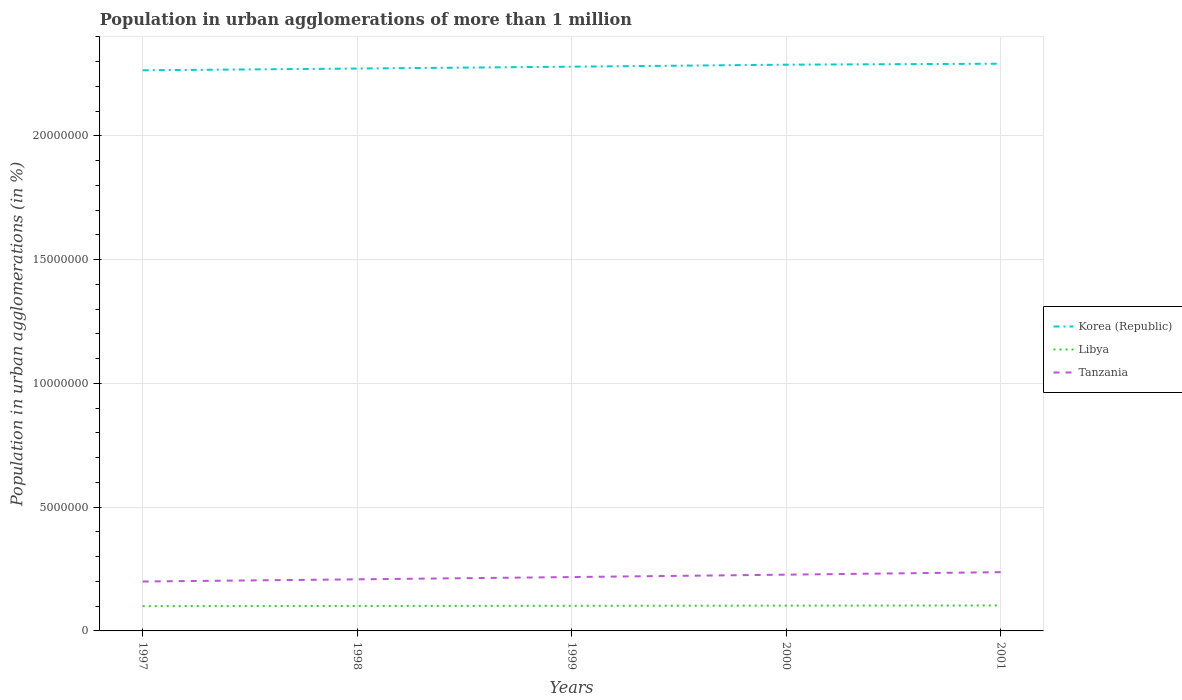How many different coloured lines are there?
Provide a succinct answer. 3. Is the number of lines equal to the number of legend labels?
Provide a succinct answer. Yes. Across all years, what is the maximum population in urban agglomerations in Korea (Republic)?
Ensure brevity in your answer.  2.26e+07. In which year was the population in urban agglomerations in Korea (Republic) maximum?
Your answer should be very brief. 1997. What is the total population in urban agglomerations in Korea (Republic) in the graph?
Your answer should be compact. -2.26e+05. What is the difference between the highest and the second highest population in urban agglomerations in Libya?
Keep it short and to the point. 2.82e+04. Is the population in urban agglomerations in Libya strictly greater than the population in urban agglomerations in Korea (Republic) over the years?
Make the answer very short. Yes. How many lines are there?
Make the answer very short. 3. Does the graph contain any zero values?
Your response must be concise. No. What is the title of the graph?
Provide a succinct answer. Population in urban agglomerations of more than 1 million. What is the label or title of the Y-axis?
Give a very brief answer. Population in urban agglomerations (in %). What is the Population in urban agglomerations (in %) of Korea (Republic) in 1997?
Make the answer very short. 2.26e+07. What is the Population in urban agglomerations (in %) of Libya in 1997?
Offer a terse response. 1.00e+06. What is the Population in urban agglomerations (in %) of Tanzania in 1997?
Give a very brief answer. 2.00e+06. What is the Population in urban agglomerations (in %) in Korea (Republic) in 1998?
Provide a succinct answer. 2.27e+07. What is the Population in urban agglomerations (in %) in Libya in 1998?
Ensure brevity in your answer.  1.01e+06. What is the Population in urban agglomerations (in %) in Tanzania in 1998?
Keep it short and to the point. 2.08e+06. What is the Population in urban agglomerations (in %) of Korea (Republic) in 1999?
Offer a very short reply. 2.28e+07. What is the Population in urban agglomerations (in %) of Libya in 1999?
Ensure brevity in your answer.  1.01e+06. What is the Population in urban agglomerations (in %) of Tanzania in 1999?
Ensure brevity in your answer.  2.18e+06. What is the Population in urban agglomerations (in %) of Korea (Republic) in 2000?
Provide a short and direct response. 2.29e+07. What is the Population in urban agglomerations (in %) in Libya in 2000?
Your response must be concise. 1.02e+06. What is the Population in urban agglomerations (in %) in Tanzania in 2000?
Offer a terse response. 2.27e+06. What is the Population in urban agglomerations (in %) of Korea (Republic) in 2001?
Make the answer very short. 2.29e+07. What is the Population in urban agglomerations (in %) in Libya in 2001?
Provide a succinct answer. 1.03e+06. What is the Population in urban agglomerations (in %) of Tanzania in 2001?
Your answer should be compact. 2.37e+06. Across all years, what is the maximum Population in urban agglomerations (in %) in Korea (Republic)?
Give a very brief answer. 2.29e+07. Across all years, what is the maximum Population in urban agglomerations (in %) in Libya?
Your answer should be very brief. 1.03e+06. Across all years, what is the maximum Population in urban agglomerations (in %) of Tanzania?
Offer a very short reply. 2.37e+06. Across all years, what is the minimum Population in urban agglomerations (in %) of Korea (Republic)?
Keep it short and to the point. 2.26e+07. Across all years, what is the minimum Population in urban agglomerations (in %) of Libya?
Your answer should be compact. 1.00e+06. Across all years, what is the minimum Population in urban agglomerations (in %) in Tanzania?
Offer a terse response. 2.00e+06. What is the total Population in urban agglomerations (in %) in Korea (Republic) in the graph?
Give a very brief answer. 1.14e+08. What is the total Population in urban agglomerations (in %) in Libya in the graph?
Give a very brief answer. 5.07e+06. What is the total Population in urban agglomerations (in %) in Tanzania in the graph?
Provide a succinct answer. 1.09e+07. What is the difference between the Population in urban agglomerations (in %) of Korea (Republic) in 1997 and that in 1998?
Provide a succinct answer. -7.04e+04. What is the difference between the Population in urban agglomerations (in %) in Libya in 1997 and that in 1998?
Provide a short and direct response. -6976. What is the difference between the Population in urban agglomerations (in %) of Tanzania in 1997 and that in 1998?
Provide a succinct answer. -8.83e+04. What is the difference between the Population in urban agglomerations (in %) in Korea (Republic) in 1997 and that in 1999?
Your response must be concise. -1.46e+05. What is the difference between the Population in urban agglomerations (in %) in Libya in 1997 and that in 1999?
Your answer should be compact. -1.40e+04. What is the difference between the Population in urban agglomerations (in %) in Tanzania in 1997 and that in 1999?
Keep it short and to the point. -1.80e+05. What is the difference between the Population in urban agglomerations (in %) of Korea (Republic) in 1997 and that in 2000?
Offer a very short reply. -2.26e+05. What is the difference between the Population in urban agglomerations (in %) in Libya in 1997 and that in 2000?
Offer a very short reply. -2.11e+04. What is the difference between the Population in urban agglomerations (in %) in Tanzania in 1997 and that in 2000?
Offer a terse response. -2.77e+05. What is the difference between the Population in urban agglomerations (in %) of Korea (Republic) in 1997 and that in 2001?
Make the answer very short. -2.66e+05. What is the difference between the Population in urban agglomerations (in %) in Libya in 1997 and that in 2001?
Your answer should be very brief. -2.82e+04. What is the difference between the Population in urban agglomerations (in %) of Tanzania in 1997 and that in 2001?
Your answer should be compact. -3.77e+05. What is the difference between the Population in urban agglomerations (in %) in Korea (Republic) in 1998 and that in 1999?
Your answer should be very brief. -7.54e+04. What is the difference between the Population in urban agglomerations (in %) of Libya in 1998 and that in 1999?
Provide a succinct answer. -7025. What is the difference between the Population in urban agglomerations (in %) in Tanzania in 1998 and that in 1999?
Provide a succinct answer. -9.22e+04. What is the difference between the Population in urban agglomerations (in %) of Korea (Republic) in 1998 and that in 2000?
Keep it short and to the point. -1.56e+05. What is the difference between the Population in urban agglomerations (in %) of Libya in 1998 and that in 2000?
Offer a terse response. -1.41e+04. What is the difference between the Population in urban agglomerations (in %) in Tanzania in 1998 and that in 2000?
Ensure brevity in your answer.  -1.89e+05. What is the difference between the Population in urban agglomerations (in %) in Korea (Republic) in 1998 and that in 2001?
Give a very brief answer. -1.96e+05. What is the difference between the Population in urban agglomerations (in %) in Libya in 1998 and that in 2001?
Give a very brief answer. -2.12e+04. What is the difference between the Population in urban agglomerations (in %) of Tanzania in 1998 and that in 2001?
Provide a short and direct response. -2.89e+05. What is the difference between the Population in urban agglomerations (in %) in Korea (Republic) in 1999 and that in 2000?
Offer a terse response. -8.06e+04. What is the difference between the Population in urban agglomerations (in %) in Libya in 1999 and that in 2000?
Your answer should be compact. -7084. What is the difference between the Population in urban agglomerations (in %) of Tanzania in 1999 and that in 2000?
Make the answer very short. -9.64e+04. What is the difference between the Population in urban agglomerations (in %) in Korea (Republic) in 1999 and that in 2001?
Offer a very short reply. -1.20e+05. What is the difference between the Population in urban agglomerations (in %) of Libya in 1999 and that in 2001?
Keep it short and to the point. -1.42e+04. What is the difference between the Population in urban agglomerations (in %) of Tanzania in 1999 and that in 2001?
Offer a very short reply. -1.97e+05. What is the difference between the Population in urban agglomerations (in %) in Korea (Republic) in 2000 and that in 2001?
Offer a very short reply. -3.99e+04. What is the difference between the Population in urban agglomerations (in %) in Libya in 2000 and that in 2001?
Provide a short and direct response. -7114. What is the difference between the Population in urban agglomerations (in %) in Tanzania in 2000 and that in 2001?
Your answer should be very brief. -1.00e+05. What is the difference between the Population in urban agglomerations (in %) in Korea (Republic) in 1997 and the Population in urban agglomerations (in %) in Libya in 1998?
Keep it short and to the point. 2.16e+07. What is the difference between the Population in urban agglomerations (in %) in Korea (Republic) in 1997 and the Population in urban agglomerations (in %) in Tanzania in 1998?
Make the answer very short. 2.06e+07. What is the difference between the Population in urban agglomerations (in %) of Libya in 1997 and the Population in urban agglomerations (in %) of Tanzania in 1998?
Keep it short and to the point. -1.08e+06. What is the difference between the Population in urban agglomerations (in %) in Korea (Republic) in 1997 and the Population in urban agglomerations (in %) in Libya in 1999?
Make the answer very short. 2.16e+07. What is the difference between the Population in urban agglomerations (in %) in Korea (Republic) in 1997 and the Population in urban agglomerations (in %) in Tanzania in 1999?
Your answer should be very brief. 2.05e+07. What is the difference between the Population in urban agglomerations (in %) of Libya in 1997 and the Population in urban agglomerations (in %) of Tanzania in 1999?
Offer a very short reply. -1.18e+06. What is the difference between the Population in urban agglomerations (in %) in Korea (Republic) in 1997 and the Population in urban agglomerations (in %) in Libya in 2000?
Offer a terse response. 2.16e+07. What is the difference between the Population in urban agglomerations (in %) in Korea (Republic) in 1997 and the Population in urban agglomerations (in %) in Tanzania in 2000?
Offer a terse response. 2.04e+07. What is the difference between the Population in urban agglomerations (in %) of Libya in 1997 and the Population in urban agglomerations (in %) of Tanzania in 2000?
Your response must be concise. -1.27e+06. What is the difference between the Population in urban agglomerations (in %) in Korea (Republic) in 1997 and the Population in urban agglomerations (in %) in Libya in 2001?
Provide a short and direct response. 2.16e+07. What is the difference between the Population in urban agglomerations (in %) of Korea (Republic) in 1997 and the Population in urban agglomerations (in %) of Tanzania in 2001?
Provide a succinct answer. 2.03e+07. What is the difference between the Population in urban agglomerations (in %) of Libya in 1997 and the Population in urban agglomerations (in %) of Tanzania in 2001?
Provide a succinct answer. -1.37e+06. What is the difference between the Population in urban agglomerations (in %) in Korea (Republic) in 1998 and the Population in urban agglomerations (in %) in Libya in 1999?
Make the answer very short. 2.17e+07. What is the difference between the Population in urban agglomerations (in %) in Korea (Republic) in 1998 and the Population in urban agglomerations (in %) in Tanzania in 1999?
Offer a terse response. 2.05e+07. What is the difference between the Population in urban agglomerations (in %) in Libya in 1998 and the Population in urban agglomerations (in %) in Tanzania in 1999?
Offer a very short reply. -1.17e+06. What is the difference between the Population in urban agglomerations (in %) in Korea (Republic) in 1998 and the Population in urban agglomerations (in %) in Libya in 2000?
Your response must be concise. 2.17e+07. What is the difference between the Population in urban agglomerations (in %) of Korea (Republic) in 1998 and the Population in urban agglomerations (in %) of Tanzania in 2000?
Give a very brief answer. 2.04e+07. What is the difference between the Population in urban agglomerations (in %) of Libya in 1998 and the Population in urban agglomerations (in %) of Tanzania in 2000?
Your response must be concise. -1.26e+06. What is the difference between the Population in urban agglomerations (in %) of Korea (Republic) in 1998 and the Population in urban agglomerations (in %) of Libya in 2001?
Give a very brief answer. 2.17e+07. What is the difference between the Population in urban agglomerations (in %) in Korea (Republic) in 1998 and the Population in urban agglomerations (in %) in Tanzania in 2001?
Offer a very short reply. 2.03e+07. What is the difference between the Population in urban agglomerations (in %) of Libya in 1998 and the Population in urban agglomerations (in %) of Tanzania in 2001?
Offer a very short reply. -1.37e+06. What is the difference between the Population in urban agglomerations (in %) of Korea (Republic) in 1999 and the Population in urban agglomerations (in %) of Libya in 2000?
Your answer should be very brief. 2.18e+07. What is the difference between the Population in urban agglomerations (in %) of Korea (Republic) in 1999 and the Population in urban agglomerations (in %) of Tanzania in 2000?
Your response must be concise. 2.05e+07. What is the difference between the Population in urban agglomerations (in %) in Libya in 1999 and the Population in urban agglomerations (in %) in Tanzania in 2000?
Offer a terse response. -1.26e+06. What is the difference between the Population in urban agglomerations (in %) of Korea (Republic) in 1999 and the Population in urban agglomerations (in %) of Libya in 2001?
Give a very brief answer. 2.18e+07. What is the difference between the Population in urban agglomerations (in %) in Korea (Republic) in 1999 and the Population in urban agglomerations (in %) in Tanzania in 2001?
Keep it short and to the point. 2.04e+07. What is the difference between the Population in urban agglomerations (in %) of Libya in 1999 and the Population in urban agglomerations (in %) of Tanzania in 2001?
Offer a terse response. -1.36e+06. What is the difference between the Population in urban agglomerations (in %) in Korea (Republic) in 2000 and the Population in urban agglomerations (in %) in Libya in 2001?
Provide a succinct answer. 2.18e+07. What is the difference between the Population in urban agglomerations (in %) in Korea (Republic) in 2000 and the Population in urban agglomerations (in %) in Tanzania in 2001?
Make the answer very short. 2.05e+07. What is the difference between the Population in urban agglomerations (in %) in Libya in 2000 and the Population in urban agglomerations (in %) in Tanzania in 2001?
Provide a short and direct response. -1.35e+06. What is the average Population in urban agglomerations (in %) in Korea (Republic) per year?
Provide a succinct answer. 2.28e+07. What is the average Population in urban agglomerations (in %) of Libya per year?
Keep it short and to the point. 1.01e+06. What is the average Population in urban agglomerations (in %) of Tanzania per year?
Give a very brief answer. 2.18e+06. In the year 1997, what is the difference between the Population in urban agglomerations (in %) in Korea (Republic) and Population in urban agglomerations (in %) in Libya?
Keep it short and to the point. 2.16e+07. In the year 1997, what is the difference between the Population in urban agglomerations (in %) of Korea (Republic) and Population in urban agglomerations (in %) of Tanzania?
Your response must be concise. 2.07e+07. In the year 1997, what is the difference between the Population in urban agglomerations (in %) in Libya and Population in urban agglomerations (in %) in Tanzania?
Keep it short and to the point. -9.95e+05. In the year 1998, what is the difference between the Population in urban agglomerations (in %) of Korea (Republic) and Population in urban agglomerations (in %) of Libya?
Provide a succinct answer. 2.17e+07. In the year 1998, what is the difference between the Population in urban agglomerations (in %) in Korea (Republic) and Population in urban agglomerations (in %) in Tanzania?
Ensure brevity in your answer.  2.06e+07. In the year 1998, what is the difference between the Population in urban agglomerations (in %) of Libya and Population in urban agglomerations (in %) of Tanzania?
Keep it short and to the point. -1.08e+06. In the year 1999, what is the difference between the Population in urban agglomerations (in %) in Korea (Republic) and Population in urban agglomerations (in %) in Libya?
Offer a very short reply. 2.18e+07. In the year 1999, what is the difference between the Population in urban agglomerations (in %) in Korea (Republic) and Population in urban agglomerations (in %) in Tanzania?
Give a very brief answer. 2.06e+07. In the year 1999, what is the difference between the Population in urban agglomerations (in %) in Libya and Population in urban agglomerations (in %) in Tanzania?
Provide a short and direct response. -1.16e+06. In the year 2000, what is the difference between the Population in urban agglomerations (in %) in Korea (Republic) and Population in urban agglomerations (in %) in Libya?
Provide a succinct answer. 2.19e+07. In the year 2000, what is the difference between the Population in urban agglomerations (in %) in Korea (Republic) and Population in urban agglomerations (in %) in Tanzania?
Offer a very short reply. 2.06e+07. In the year 2000, what is the difference between the Population in urban agglomerations (in %) of Libya and Population in urban agglomerations (in %) of Tanzania?
Your answer should be compact. -1.25e+06. In the year 2001, what is the difference between the Population in urban agglomerations (in %) in Korea (Republic) and Population in urban agglomerations (in %) in Libya?
Provide a short and direct response. 2.19e+07. In the year 2001, what is the difference between the Population in urban agglomerations (in %) in Korea (Republic) and Population in urban agglomerations (in %) in Tanzania?
Your response must be concise. 2.05e+07. In the year 2001, what is the difference between the Population in urban agglomerations (in %) in Libya and Population in urban agglomerations (in %) in Tanzania?
Provide a succinct answer. -1.34e+06. What is the ratio of the Population in urban agglomerations (in %) in Korea (Republic) in 1997 to that in 1998?
Ensure brevity in your answer.  1. What is the ratio of the Population in urban agglomerations (in %) in Libya in 1997 to that in 1998?
Keep it short and to the point. 0.99. What is the ratio of the Population in urban agglomerations (in %) in Tanzania in 1997 to that in 1998?
Provide a succinct answer. 0.96. What is the ratio of the Population in urban agglomerations (in %) of Korea (Republic) in 1997 to that in 1999?
Provide a short and direct response. 0.99. What is the ratio of the Population in urban agglomerations (in %) of Libya in 1997 to that in 1999?
Provide a succinct answer. 0.99. What is the ratio of the Population in urban agglomerations (in %) of Tanzania in 1997 to that in 1999?
Your response must be concise. 0.92. What is the ratio of the Population in urban agglomerations (in %) in Libya in 1997 to that in 2000?
Give a very brief answer. 0.98. What is the ratio of the Population in urban agglomerations (in %) in Tanzania in 1997 to that in 2000?
Give a very brief answer. 0.88. What is the ratio of the Population in urban agglomerations (in %) of Korea (Republic) in 1997 to that in 2001?
Offer a very short reply. 0.99. What is the ratio of the Population in urban agglomerations (in %) of Libya in 1997 to that in 2001?
Offer a terse response. 0.97. What is the ratio of the Population in urban agglomerations (in %) of Tanzania in 1997 to that in 2001?
Provide a succinct answer. 0.84. What is the ratio of the Population in urban agglomerations (in %) of Tanzania in 1998 to that in 1999?
Keep it short and to the point. 0.96. What is the ratio of the Population in urban agglomerations (in %) of Korea (Republic) in 1998 to that in 2000?
Keep it short and to the point. 0.99. What is the ratio of the Population in urban agglomerations (in %) of Libya in 1998 to that in 2000?
Offer a terse response. 0.99. What is the ratio of the Population in urban agglomerations (in %) in Tanzania in 1998 to that in 2000?
Your answer should be compact. 0.92. What is the ratio of the Population in urban agglomerations (in %) in Libya in 1998 to that in 2001?
Provide a succinct answer. 0.98. What is the ratio of the Population in urban agglomerations (in %) in Tanzania in 1998 to that in 2001?
Offer a terse response. 0.88. What is the ratio of the Population in urban agglomerations (in %) of Korea (Republic) in 1999 to that in 2000?
Keep it short and to the point. 1. What is the ratio of the Population in urban agglomerations (in %) in Libya in 1999 to that in 2000?
Ensure brevity in your answer.  0.99. What is the ratio of the Population in urban agglomerations (in %) in Tanzania in 1999 to that in 2000?
Offer a terse response. 0.96. What is the ratio of the Population in urban agglomerations (in %) of Korea (Republic) in 1999 to that in 2001?
Offer a very short reply. 0.99. What is the ratio of the Population in urban agglomerations (in %) of Libya in 1999 to that in 2001?
Offer a very short reply. 0.99. What is the ratio of the Population in urban agglomerations (in %) in Tanzania in 1999 to that in 2001?
Offer a very short reply. 0.92. What is the ratio of the Population in urban agglomerations (in %) in Tanzania in 2000 to that in 2001?
Give a very brief answer. 0.96. What is the difference between the highest and the second highest Population in urban agglomerations (in %) of Korea (Republic)?
Your response must be concise. 3.99e+04. What is the difference between the highest and the second highest Population in urban agglomerations (in %) of Libya?
Your answer should be compact. 7114. What is the difference between the highest and the second highest Population in urban agglomerations (in %) in Tanzania?
Your answer should be compact. 1.00e+05. What is the difference between the highest and the lowest Population in urban agglomerations (in %) of Korea (Republic)?
Your response must be concise. 2.66e+05. What is the difference between the highest and the lowest Population in urban agglomerations (in %) in Libya?
Your answer should be compact. 2.82e+04. What is the difference between the highest and the lowest Population in urban agglomerations (in %) in Tanzania?
Your answer should be compact. 3.77e+05. 